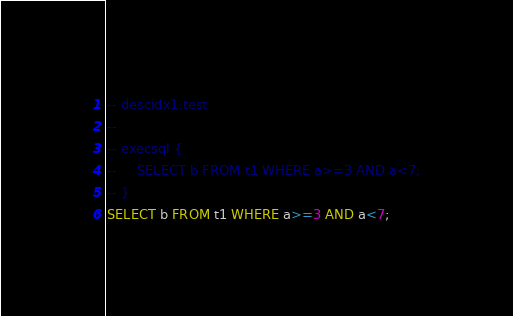Convert code to text. <code><loc_0><loc_0><loc_500><loc_500><_SQL_>-- descidx1.test
-- 
-- execsql {
--     SELECT b FROM t1 WHERE a>=3 AND a<7;
-- }
SELECT b FROM t1 WHERE a>=3 AND a<7;</code> 